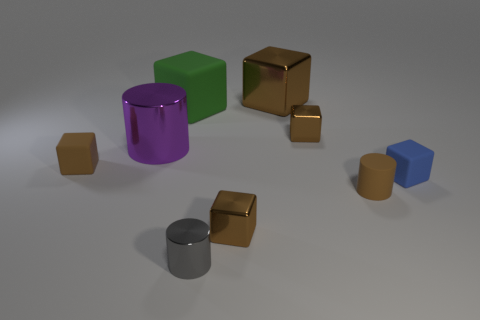Is the big cylinder the same color as the large metallic cube? No, the big cylinder and the large metallic cube are not the same color. The big cylinder has a purple hue, while the large metallic cube has a golden reflection, showcasing their distinct coloration. 